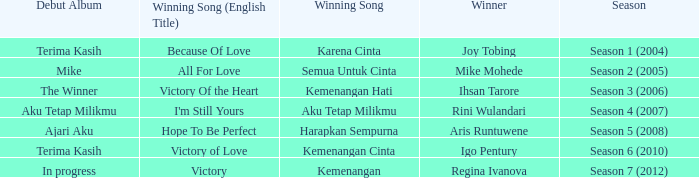Which English winning song had the winner aris runtuwene? Hope To Be Perfect. 